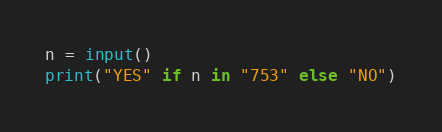<code> <loc_0><loc_0><loc_500><loc_500><_Python_>n = input()
print("YES" if n in "753" else "NO")</code> 